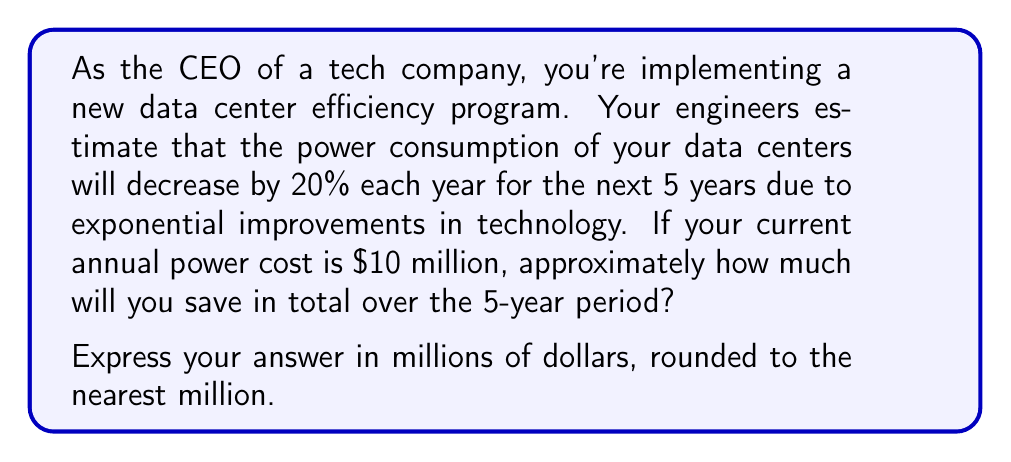Solve this math problem. Let's approach this step-by-step:

1) First, we need to calculate the power cost for each year:

   Year 0 (current): $10 million
   Year 1: $10 million × (1 - 0.20) = $8 million
   Year 2: $8 million × (1 - 0.20) = $6.4 million
   Year 3: $6.4 million × (1 - 0.20) = $5.12 million
   Year 4: $5.12 million × (1 - 0.20) = $4.096 million
   Year 5: $4.096 million × (1 - 0.20) = $3.2768 million

2) We can express this mathematically as:

   Cost in year n = $10 million × $(0.8)^n$

3) To calculate the total savings, we need to sum up the difference between the original cost ($10 million) and the cost for each year:

   Total Savings = $\sum_{n=1}^{5} (10 - 10 × (0.8)^n)$ million

4) Let's calculate this sum:

   Year 1 savings: 10 - 8 = 2
   Year 2 savings: 10 - 6.4 = 3.6
   Year 3 savings: 10 - 5.12 = 4.88
   Year 4 savings: 10 - 4.096 = 5.904
   Year 5 savings: 10 - 3.2768 = 6.7232

5) Total savings: 2 + 3.6 + 4.88 + 5.904 + 6.7232 = 23.1072 million

6) Rounding to the nearest million: 23 million
Answer: $23 million 